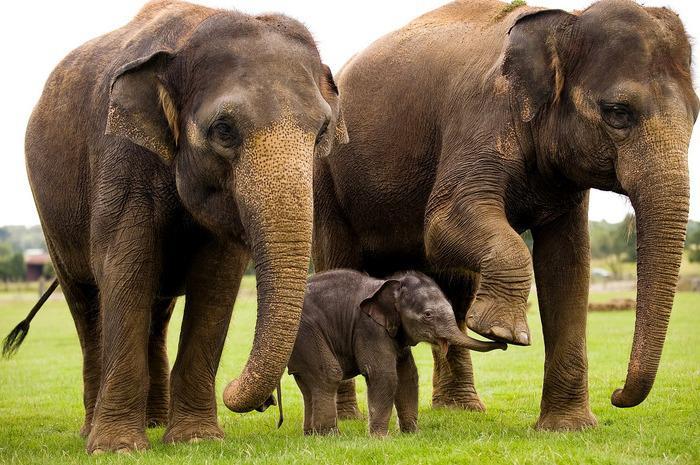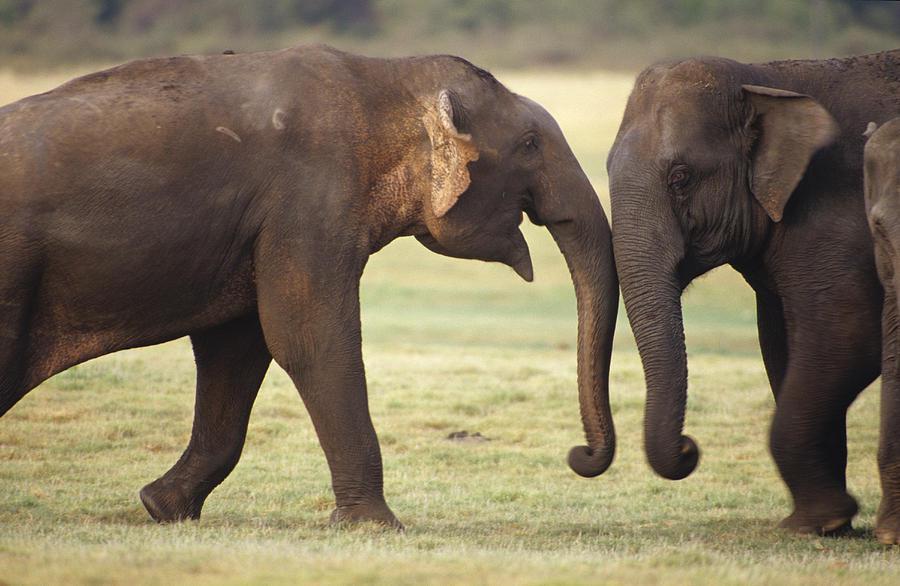The first image is the image on the left, the second image is the image on the right. Analyze the images presented: Is the assertion "The elephants in the image on the right are butting heads." valid? Answer yes or no. Yes. The first image is the image on the left, the second image is the image on the right. Assess this claim about the two images: "An image shows two adult elephants next to a baby elephant.". Correct or not? Answer yes or no. Yes. 